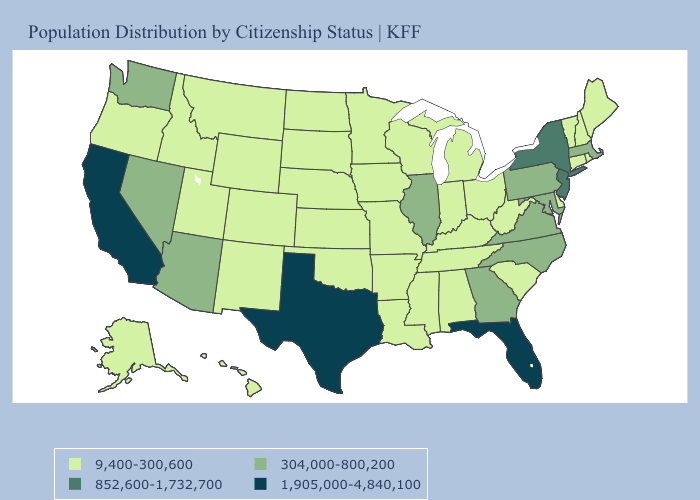Does New York have the lowest value in the USA?
Be succinct. No. Does Pennsylvania have the same value as Utah?
Concise answer only. No. What is the highest value in the USA?
Write a very short answer. 1,905,000-4,840,100. What is the highest value in the USA?
Quick response, please. 1,905,000-4,840,100. Does Colorado have the highest value in the West?
Concise answer only. No. What is the highest value in states that border Vermont?
Keep it brief. 852,600-1,732,700. Among the states that border Wyoming , which have the lowest value?
Write a very short answer. Colorado, Idaho, Montana, Nebraska, South Dakota, Utah. What is the value of Georgia?
Give a very brief answer. 304,000-800,200. What is the value of South Carolina?
Quick response, please. 9,400-300,600. Which states have the lowest value in the USA?
Short answer required. Alabama, Alaska, Arkansas, Colorado, Connecticut, Delaware, Hawaii, Idaho, Indiana, Iowa, Kansas, Kentucky, Louisiana, Maine, Michigan, Minnesota, Mississippi, Missouri, Montana, Nebraska, New Hampshire, New Mexico, North Dakota, Ohio, Oklahoma, Oregon, Rhode Island, South Carolina, South Dakota, Tennessee, Utah, Vermont, West Virginia, Wisconsin, Wyoming. Does Ohio have a lower value than Wyoming?
Concise answer only. No. What is the lowest value in states that border Florida?
Be succinct. 9,400-300,600. Which states have the highest value in the USA?
Short answer required. California, Florida, Texas. Does California have the highest value in the USA?
Give a very brief answer. Yes. What is the highest value in the USA?
Answer briefly. 1,905,000-4,840,100. 